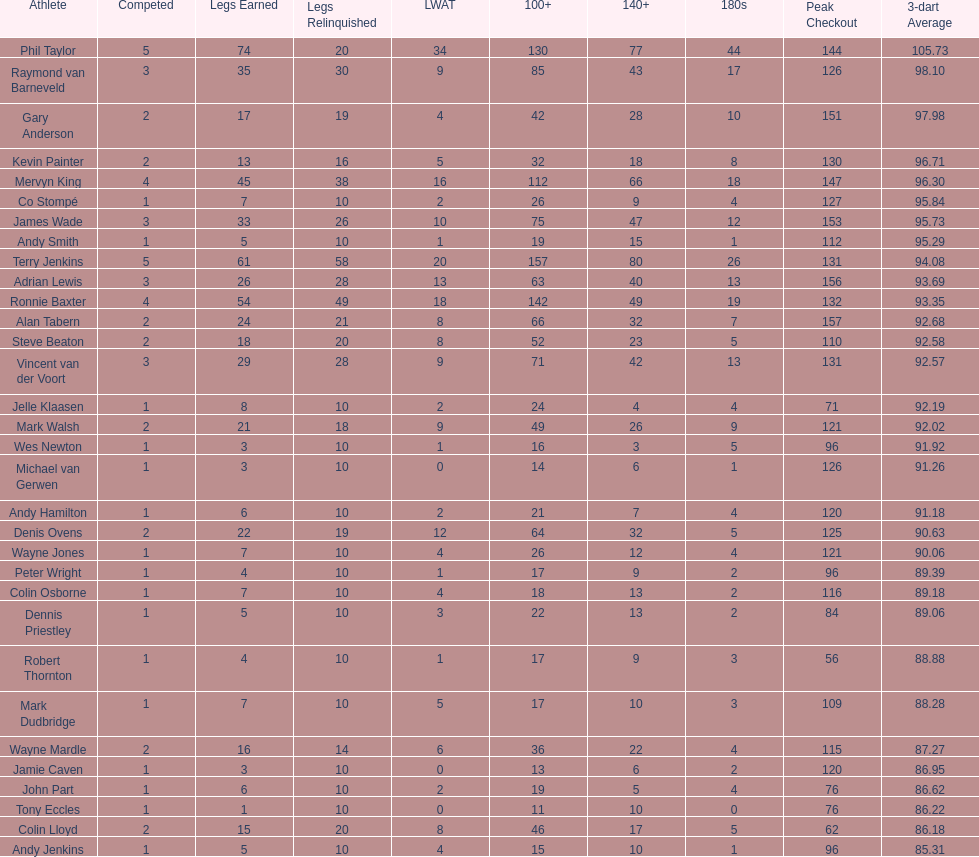Who won the highest number of legs in the 2009 world matchplay? Phil Taylor. 